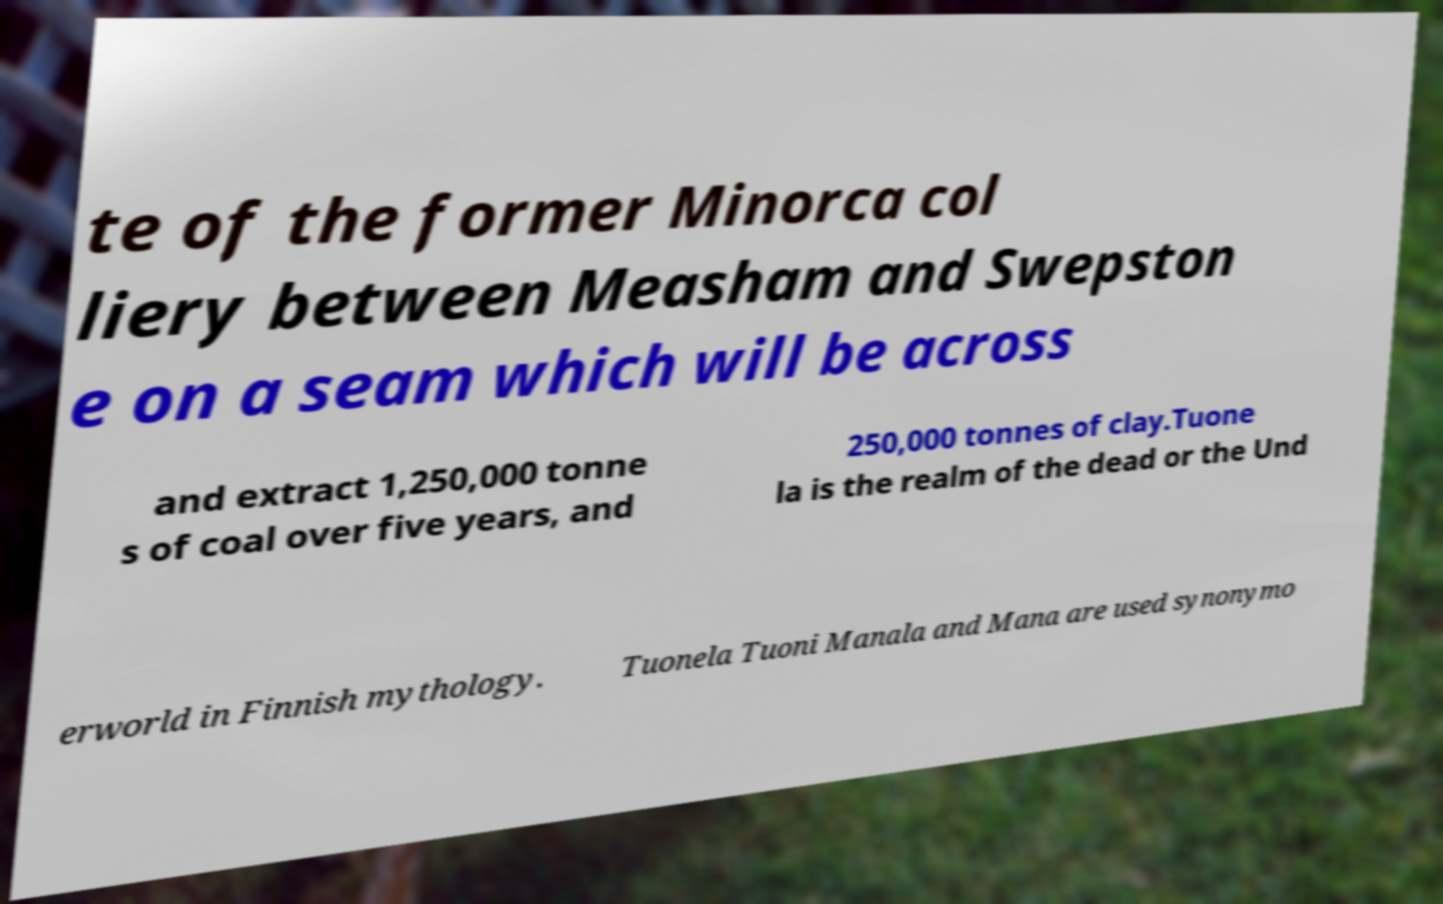Can you accurately transcribe the text from the provided image for me? te of the former Minorca col liery between Measham and Swepston e on a seam which will be across and extract 1,250,000 tonne s of coal over five years, and 250,000 tonnes of clay.Tuone la is the realm of the dead or the Und erworld in Finnish mythology. Tuonela Tuoni Manala and Mana are used synonymo 